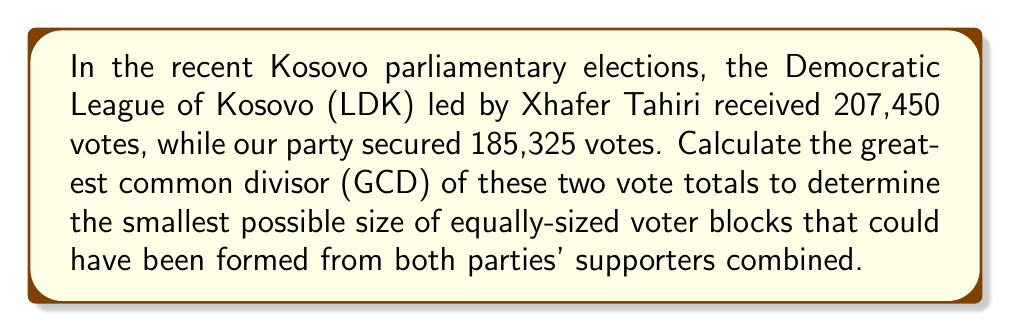Can you solve this math problem? To find the greatest common divisor (GCD) of 207,450 and 185,325, we'll use the Euclidean algorithm:

1) First, set up the initial equation:
   $207,450 = 1 \times 185,325 + 22,125$

2) Now, divide 185,325 by 22,125:
   $185,325 = 8 \times 22,125 + 9,325$

3) Continue the process:
   $22,125 = 2 \times 9,325 + 3,475$
   $9,325 = 2 \times 3,475 + 2,375$
   $3,475 = 1 \times 2,375 + 1,100$
   $2,375 = 2 \times 1,100 + 175$
   $1,100 = 6 \times 175 + 50$
   $175 = 3 \times 50 + 25$
   $50 = 2 \times 25 + 0$

4) The process stops when we get a remainder of 0. The last non-zero remainder is the GCD.

Therefore, the GCD of 207,450 and 185,325 is 25.

This means that the smallest possible size of equally-sized voter blocks that could have been formed from both parties' supporters combined is 25 voters per block.
Answer: 25 